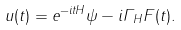Convert formula to latex. <formula><loc_0><loc_0><loc_500><loc_500>u ( t ) = e ^ { - i t H } \psi - i \Gamma _ { H } F ( t ) .</formula> 